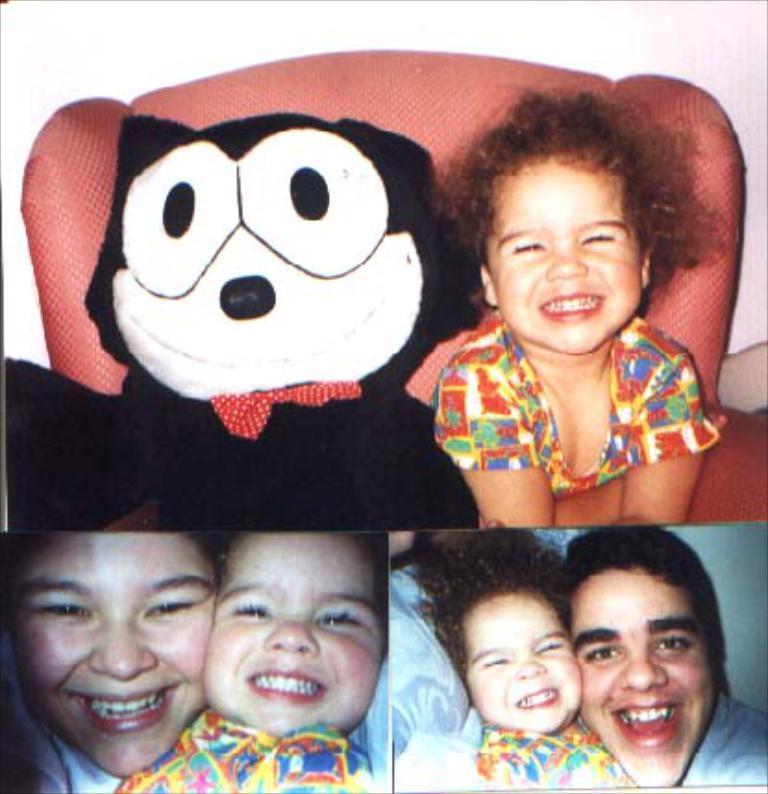Could you give a brief overview of what you see in this image? This image consists of two persons. It looks like it is edited and made as a collage. And we can see a teddy in black color. In the background, there is a wall. The girl is sitting in a sofa. 